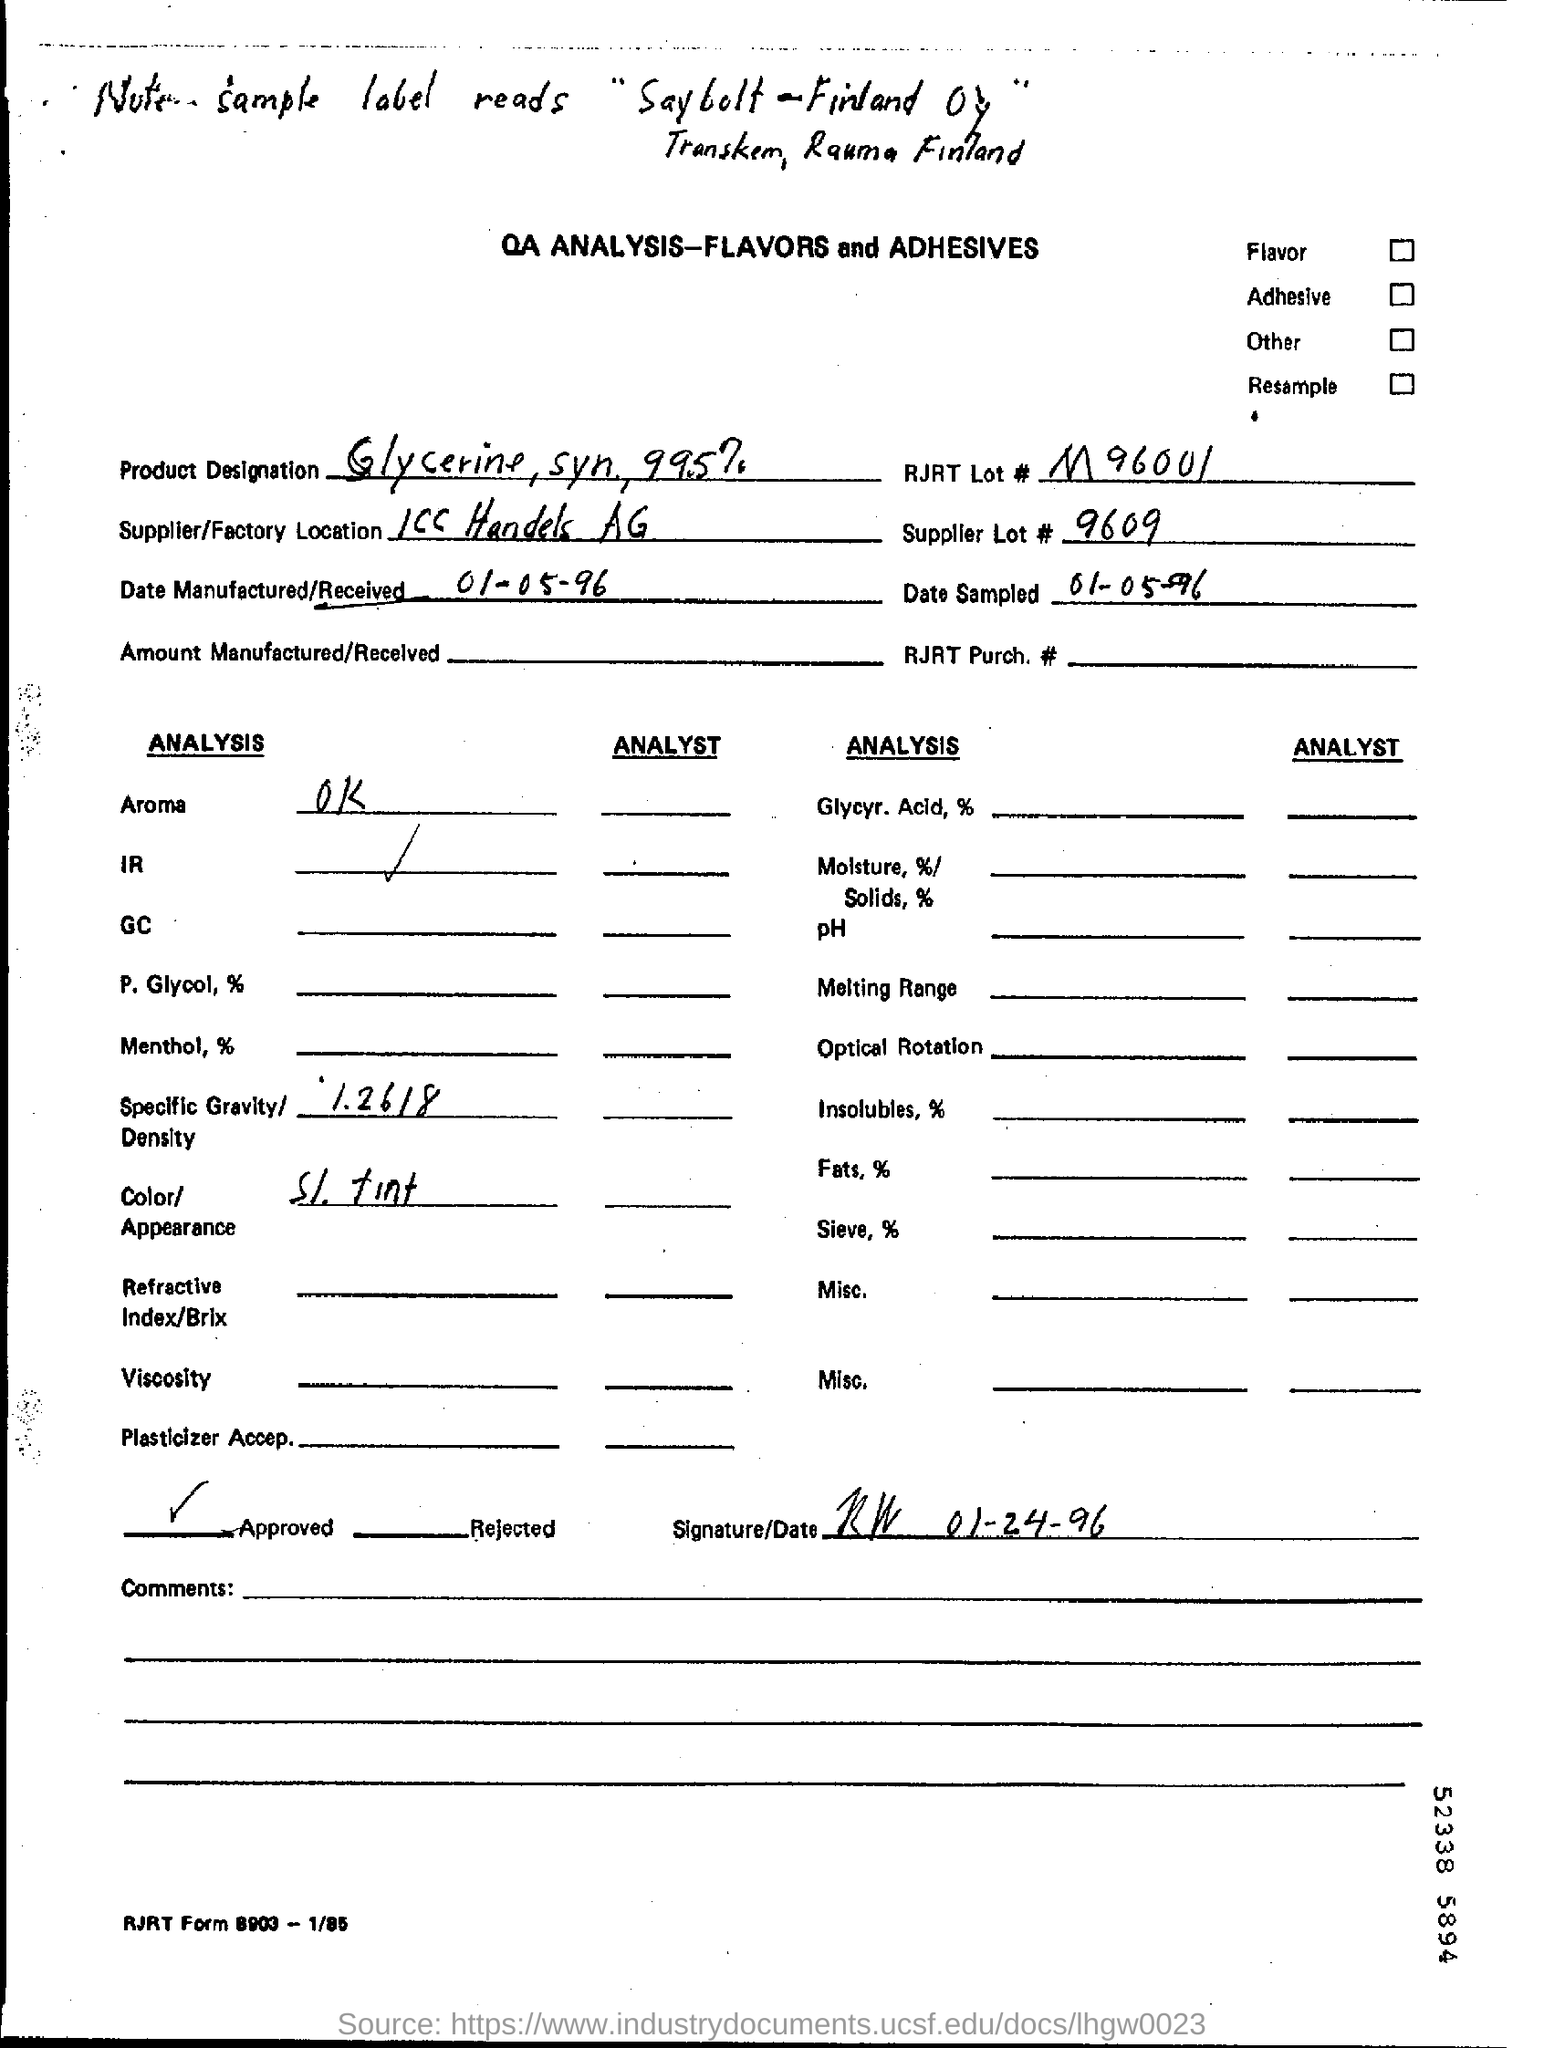Point out several critical features in this image. The date manufactured/received is 01-05-96. The specific gravity/density of the sample is 1.2618, as reported in the analysis. The color or appearance described in the analysis is SI (Spectral Iridescence). The tint of the stone is a colorless finish with a subtle shine. 